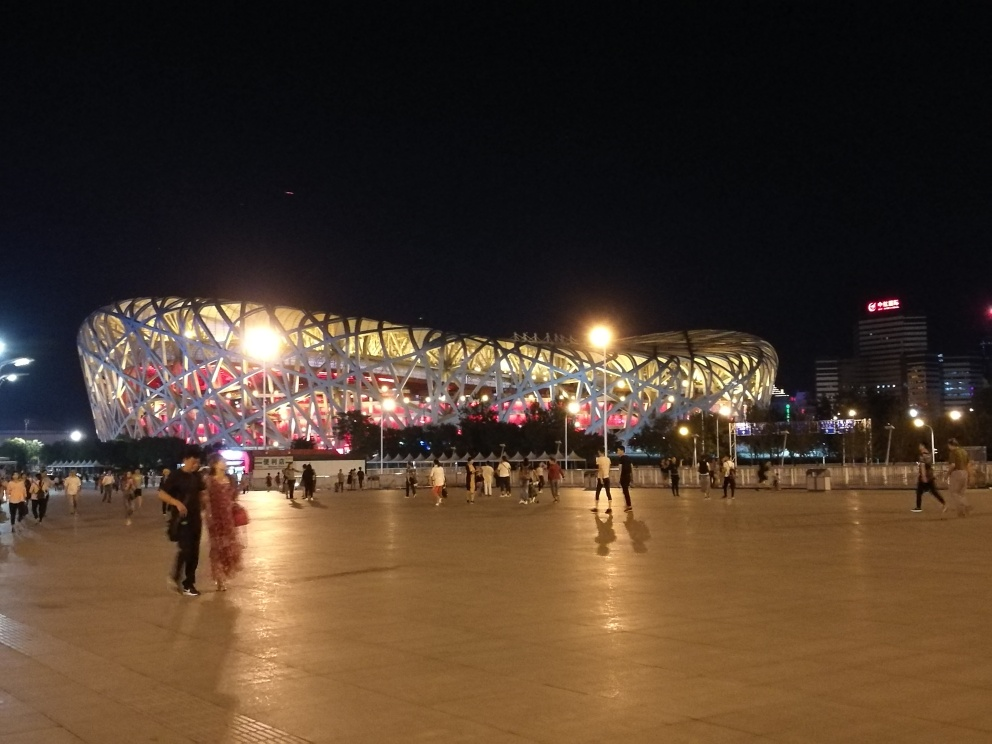What is the architectural style of the building in the image? The building features a contemporary architectural style known for its unique steel structure that creates a geometric, nest-like appearance. 